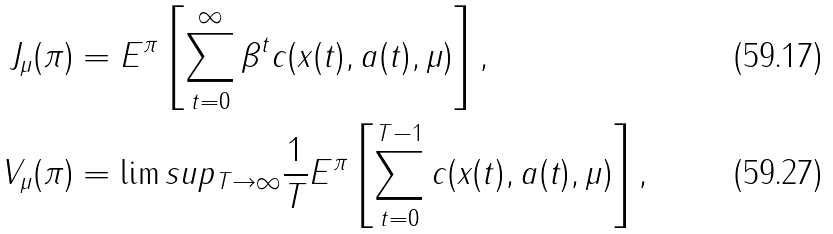<formula> <loc_0><loc_0><loc_500><loc_500>J _ { \mu } ( \pi ) & = E ^ { \pi } \left [ \sum _ { t = 0 } ^ { \infty } \beta ^ { t } c ( x ( t ) , a ( t ) , \mu ) \right ] , \\ V _ { \mu } ( \pi ) & = \lim s u p _ { T \rightarrow \infty } \frac { 1 } { T } E ^ { \pi } \left [ \sum _ { t = 0 } ^ { T - 1 } c ( x ( t ) , a ( t ) , \mu ) \right ] ,</formula> 